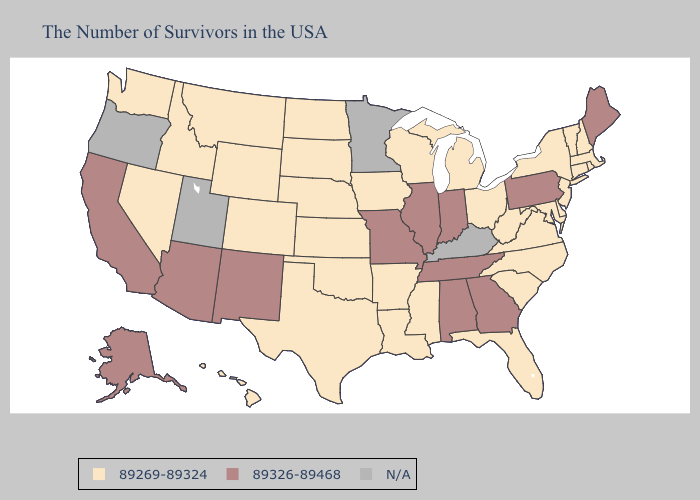Among the states that border New Hampshire , does Massachusetts have the highest value?
Short answer required. No. What is the highest value in states that border North Dakota?
Give a very brief answer. 89269-89324. What is the highest value in the South ?
Write a very short answer. 89326-89468. What is the lowest value in the MidWest?
Write a very short answer. 89269-89324. What is the value of California?
Quick response, please. 89326-89468. Which states hav the highest value in the Northeast?
Keep it brief. Maine, Pennsylvania. Which states have the lowest value in the Northeast?
Write a very short answer. Massachusetts, Rhode Island, New Hampshire, Vermont, Connecticut, New York, New Jersey. Name the states that have a value in the range N/A?
Keep it brief. Kentucky, Minnesota, Utah, Oregon. What is the value of Wisconsin?
Keep it brief. 89269-89324. Name the states that have a value in the range 89326-89468?
Give a very brief answer. Maine, Pennsylvania, Georgia, Indiana, Alabama, Tennessee, Illinois, Missouri, New Mexico, Arizona, California, Alaska. What is the highest value in the USA?
Concise answer only. 89326-89468. What is the highest value in the USA?
Short answer required. 89326-89468. Which states hav the highest value in the West?
Quick response, please. New Mexico, Arizona, California, Alaska. Among the states that border Kentucky , does Ohio have the highest value?
Concise answer only. No. 